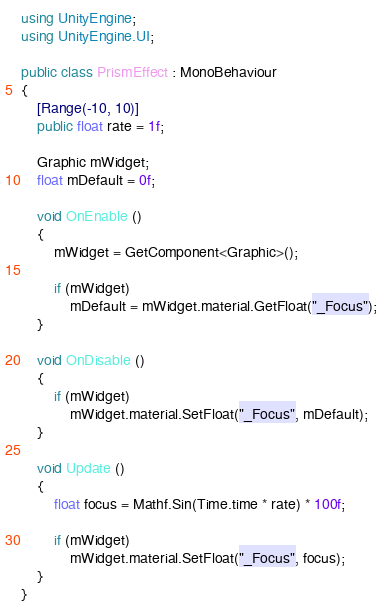Convert code to text. <code><loc_0><loc_0><loc_500><loc_500><_C#_>using UnityEngine;
using UnityEngine.UI;

public class PrismEffect : MonoBehaviour
{
	[Range(-10, 10)]
	public float rate = 1f;

	Graphic mWidget;
	float mDefault = 0f;

	void OnEnable ()
	{
		mWidget = GetComponent<Graphic>();
		
		if (mWidget)
			mDefault = mWidget.material.GetFloat("_Focus");
	}

	void OnDisable ()
	{
		if (mWidget)
			mWidget.material.SetFloat("_Focus", mDefault);
	}

	void Update ()
	{
		float focus = Mathf.Sin(Time.time * rate) * 100f;

		if (mWidget)
			mWidget.material.SetFloat("_Focus", focus);
	}
}
</code> 